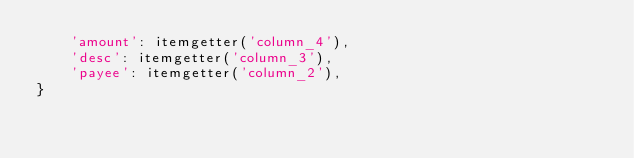<code> <loc_0><loc_0><loc_500><loc_500><_Python_>    'amount': itemgetter('column_4'),
    'desc': itemgetter('column_3'),
    'payee': itemgetter('column_2'),
}
</code> 